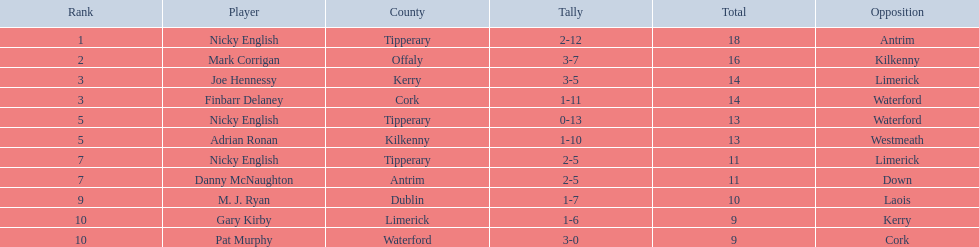Which players from the given options were positioned in the last 5 spots? Nicky English, Danny McNaughton, M. J. Ryan, Gary Kirby, Pat Murphy. Among them, who didn't have scores ranging from 2 to 5? M. J. Ryan, Gary Kirby, Pat Murphy. Out of the top three, who managed to score more than 9 points in total? M. J. Ryan. 